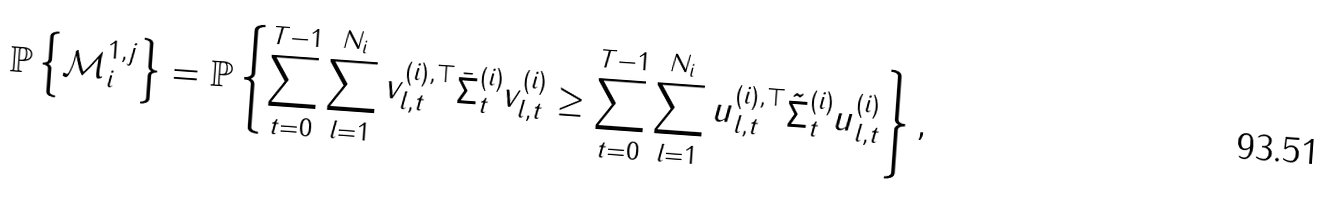<formula> <loc_0><loc_0><loc_500><loc_500>\mathbb { P } \left \{ \mathcal { M } _ { i } ^ { 1 , j } \right \} & = \mathbb { P } \left \{ \sum _ { t = 0 } ^ { T - 1 } \sum _ { l = 1 } ^ { N _ { i } } v ^ { ( i ) , \top } _ { l , t } \bar { \Sigma } ^ { ( i ) } _ { t } v ^ { ( i ) } _ { l , t } \geq \sum _ { t = 0 } ^ { T - 1 } \sum _ { l = 1 } ^ { N _ { i } } u ^ { ( i ) , \top } _ { l , t } \tilde { \Sigma } ^ { ( i ) } _ { t } u ^ { ( i ) } _ { l , t } \right \} ,</formula> 